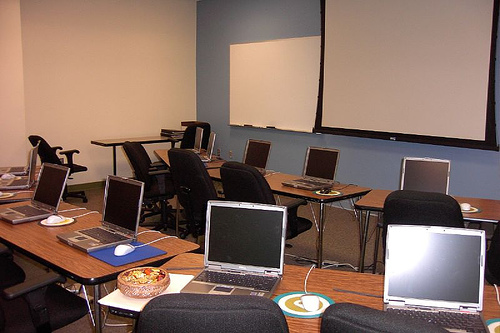Can you tell me more about the objects on the table apart from the laptops? Aside from the laptops, there's a variety of items including notepads for taking notes, pens, and what appears to be a plate possibly with snacks or refreshments for the meeting participants. 